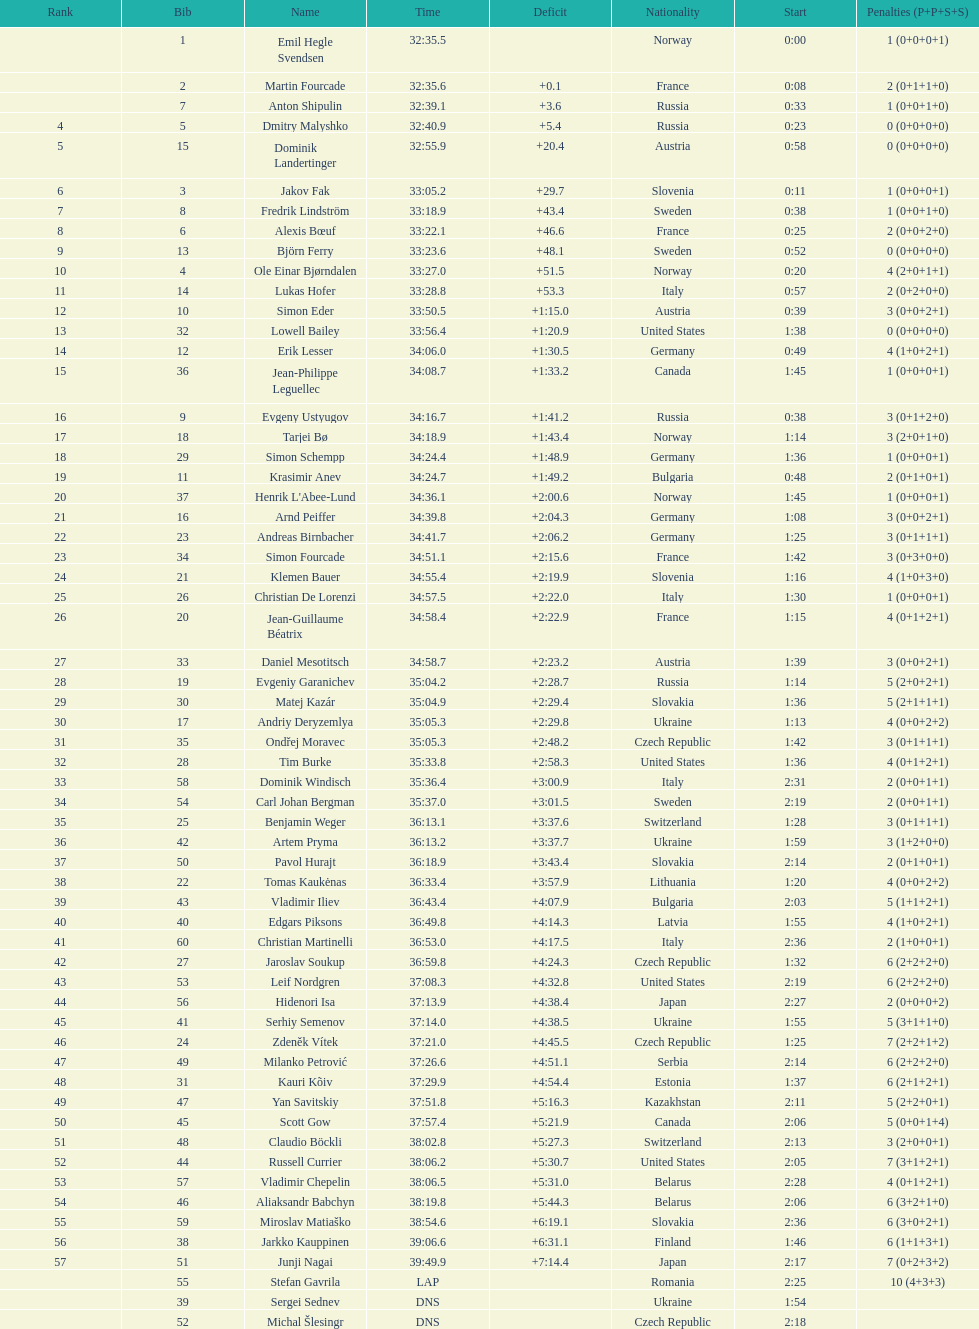What were the total number of "ties" (people who finished with the exact same time?) 2. 